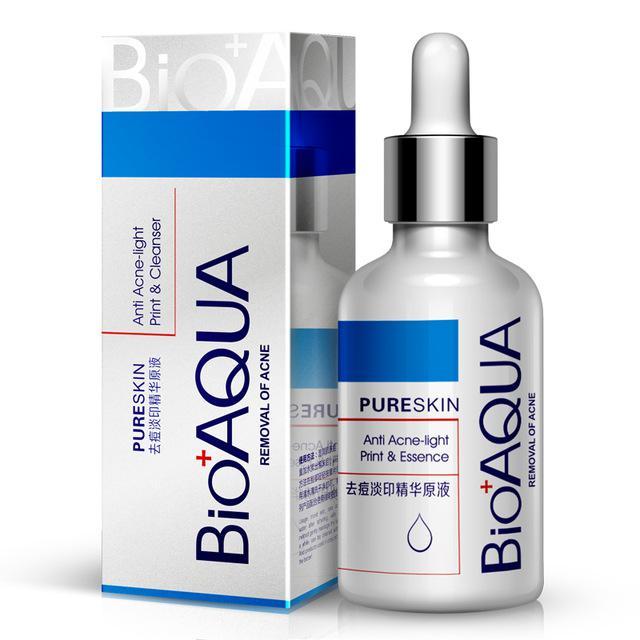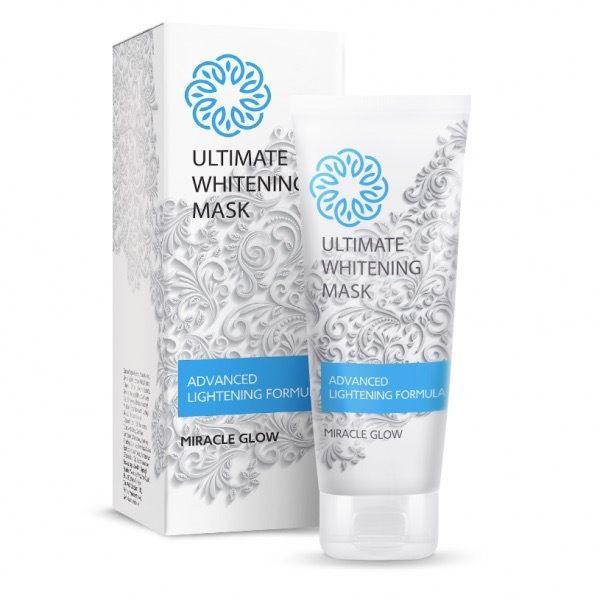The first image is the image on the left, the second image is the image on the right. Assess this claim about the two images: "The right image shows a tube product standing on its cap to the right of its upright box.". Correct or not? Answer yes or no. Yes. The first image is the image on the left, the second image is the image on the right. For the images displayed, is the sentence "The left and right image contains the same number of  boxes and face cream bottles." factually correct? Answer yes or no. Yes. 